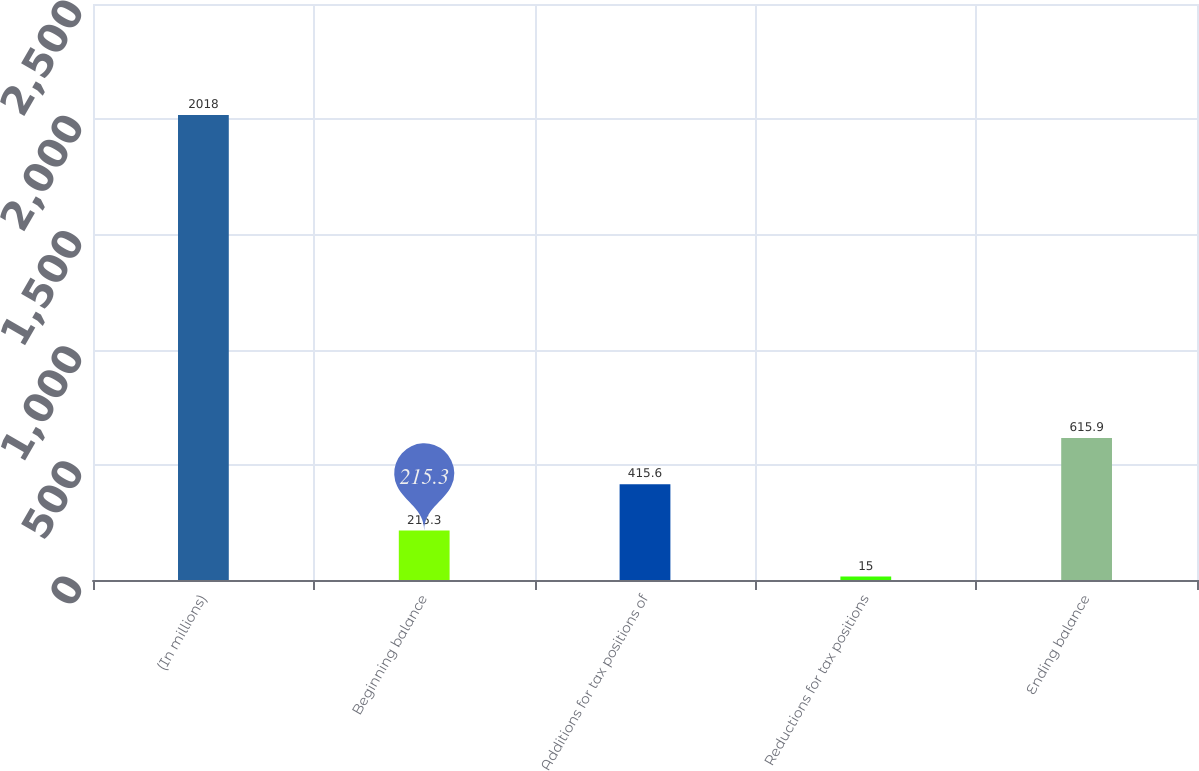Convert chart to OTSL. <chart><loc_0><loc_0><loc_500><loc_500><bar_chart><fcel>(In millions)<fcel>Beginning balance<fcel>Additions for tax positions of<fcel>Reductions for tax positions<fcel>Ending balance<nl><fcel>2018<fcel>215.3<fcel>415.6<fcel>15<fcel>615.9<nl></chart> 